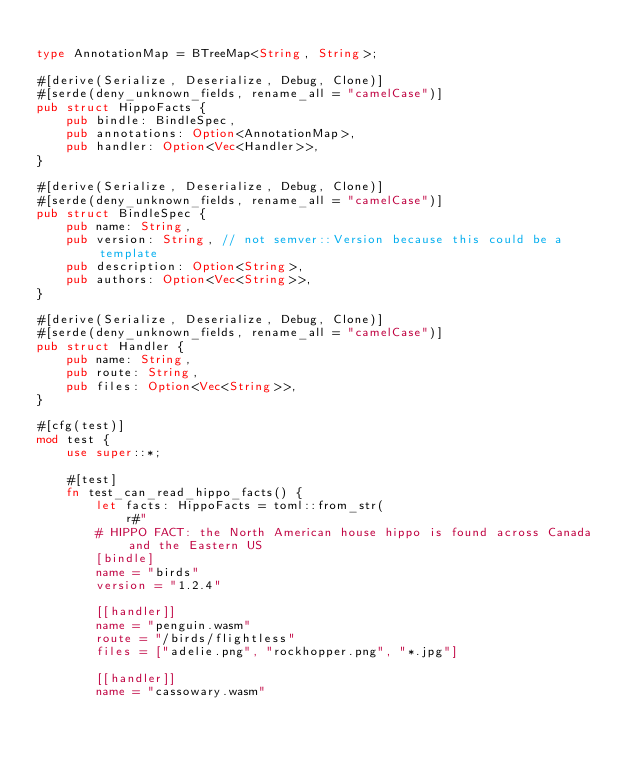Convert code to text. <code><loc_0><loc_0><loc_500><loc_500><_Rust_>
type AnnotationMap = BTreeMap<String, String>;

#[derive(Serialize, Deserialize, Debug, Clone)]
#[serde(deny_unknown_fields, rename_all = "camelCase")]
pub struct HippoFacts {
    pub bindle: BindleSpec,
    pub annotations: Option<AnnotationMap>,
    pub handler: Option<Vec<Handler>>,
}

#[derive(Serialize, Deserialize, Debug, Clone)]
#[serde(deny_unknown_fields, rename_all = "camelCase")]
pub struct BindleSpec {
    pub name: String,
    pub version: String, // not semver::Version because this could be a template
    pub description: Option<String>,
    pub authors: Option<Vec<String>>,
}

#[derive(Serialize, Deserialize, Debug, Clone)]
#[serde(deny_unknown_fields, rename_all = "camelCase")]
pub struct Handler {
    pub name: String,
    pub route: String,
    pub files: Option<Vec<String>>,
}

#[cfg(test)]
mod test {
    use super::*;

    #[test]
    fn test_can_read_hippo_facts() {
        let facts: HippoFacts = toml::from_str(
            r#"
        # HIPPO FACT: the North American house hippo is found across Canada and the Eastern US
        [bindle]
        name = "birds"
        version = "1.2.4"

        [[handler]]
        name = "penguin.wasm"
        route = "/birds/flightless"
        files = ["adelie.png", "rockhopper.png", "*.jpg"]

        [[handler]]
        name = "cassowary.wasm"</code> 